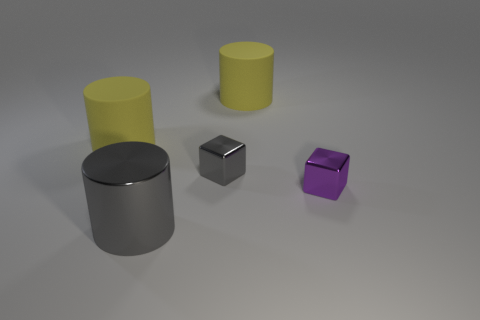Subtract all yellow cubes. How many yellow cylinders are left? 2 Subtract all large gray cylinders. How many cylinders are left? 2 Add 2 tiny purple objects. How many objects exist? 7 Subtract all cubes. How many objects are left? 3 Subtract all large yellow metal blocks. Subtract all big cylinders. How many objects are left? 2 Add 4 gray shiny cylinders. How many gray shiny cylinders are left? 5 Add 3 tiny metallic cubes. How many tiny metallic cubes exist? 5 Subtract 0 yellow blocks. How many objects are left? 5 